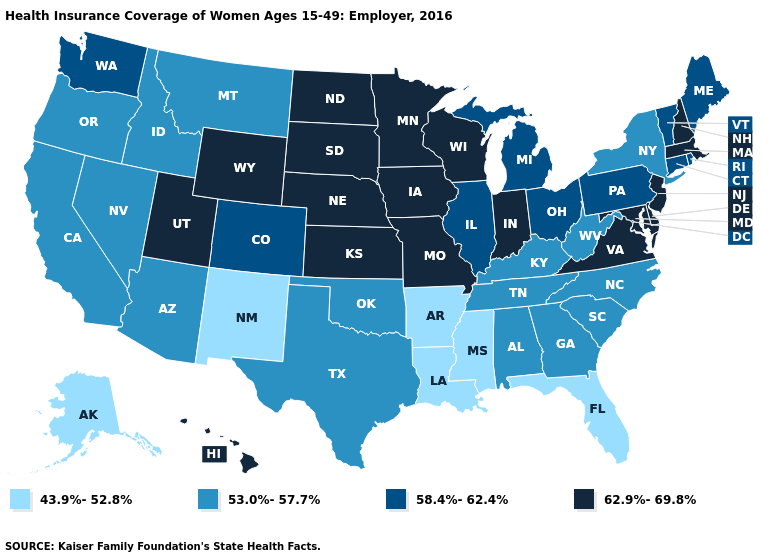What is the value of Nebraska?
Concise answer only. 62.9%-69.8%. Name the states that have a value in the range 58.4%-62.4%?
Quick response, please. Colorado, Connecticut, Illinois, Maine, Michigan, Ohio, Pennsylvania, Rhode Island, Vermont, Washington. What is the value of Alaska?
Give a very brief answer. 43.9%-52.8%. What is the lowest value in states that border New Hampshire?
Give a very brief answer. 58.4%-62.4%. Does Illinois have the highest value in the USA?
Concise answer only. No. Name the states that have a value in the range 58.4%-62.4%?
Write a very short answer. Colorado, Connecticut, Illinois, Maine, Michigan, Ohio, Pennsylvania, Rhode Island, Vermont, Washington. How many symbols are there in the legend?
Concise answer only. 4. What is the highest value in states that border Mississippi?
Answer briefly. 53.0%-57.7%. How many symbols are there in the legend?
Concise answer only. 4. Does the map have missing data?
Write a very short answer. No. Does California have a higher value than Alaska?
Be succinct. Yes. Name the states that have a value in the range 53.0%-57.7%?
Concise answer only. Alabama, Arizona, California, Georgia, Idaho, Kentucky, Montana, Nevada, New York, North Carolina, Oklahoma, Oregon, South Carolina, Tennessee, Texas, West Virginia. Among the states that border West Virginia , which have the lowest value?
Quick response, please. Kentucky. What is the value of Alabama?
Be succinct. 53.0%-57.7%. Which states have the lowest value in the South?
Be succinct. Arkansas, Florida, Louisiana, Mississippi. 